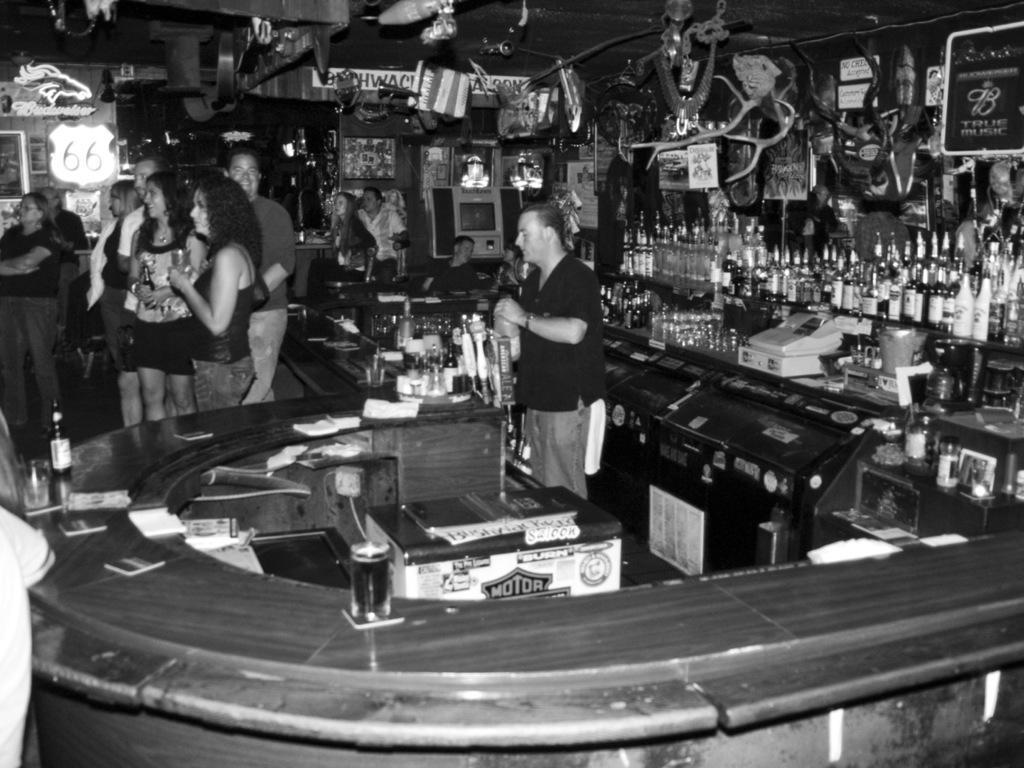In one or two sentences, can you explain what this image depicts? This picture seems to be clicked inside the room. On the right we can see there are many number of bottles and we can see there are some objects hanging on the roof and we can see the group of persons holding some objects and standing. In the background we can see the wall, group of persons and many number of objects. 